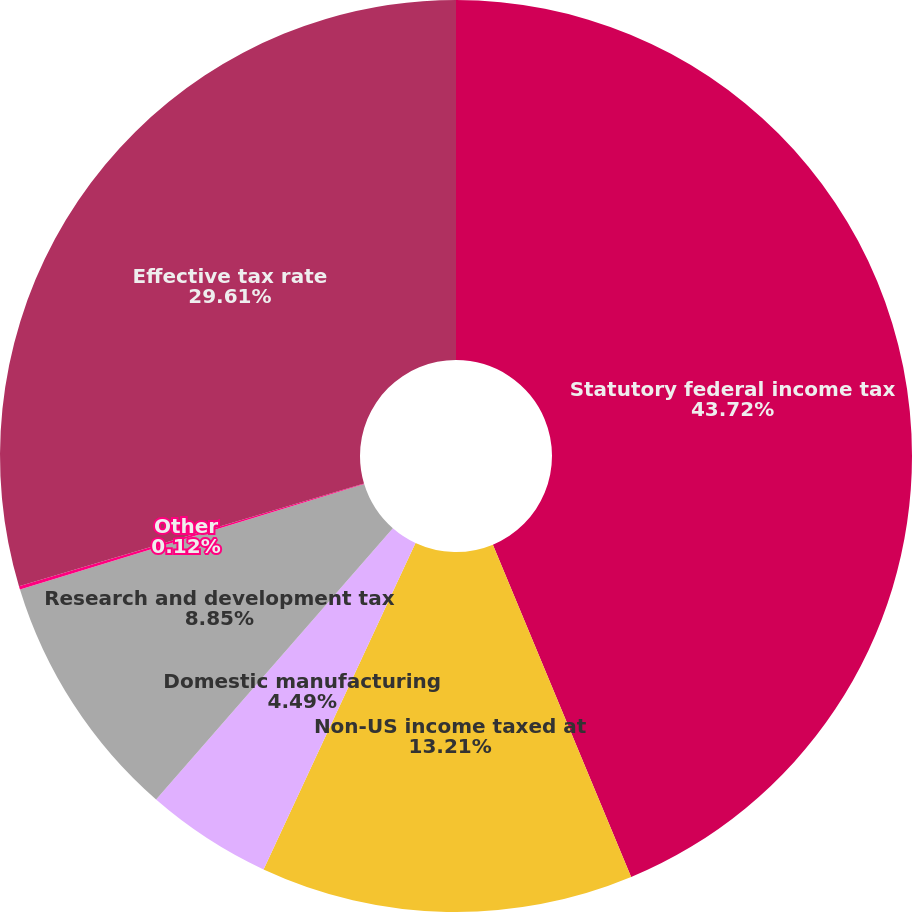Convert chart to OTSL. <chart><loc_0><loc_0><loc_500><loc_500><pie_chart><fcel>Statutory federal income tax<fcel>Non-US income taxed at<fcel>Domestic manufacturing<fcel>Research and development tax<fcel>Other<fcel>Effective tax rate<nl><fcel>43.73%<fcel>13.21%<fcel>4.49%<fcel>8.85%<fcel>0.12%<fcel>29.61%<nl></chart> 